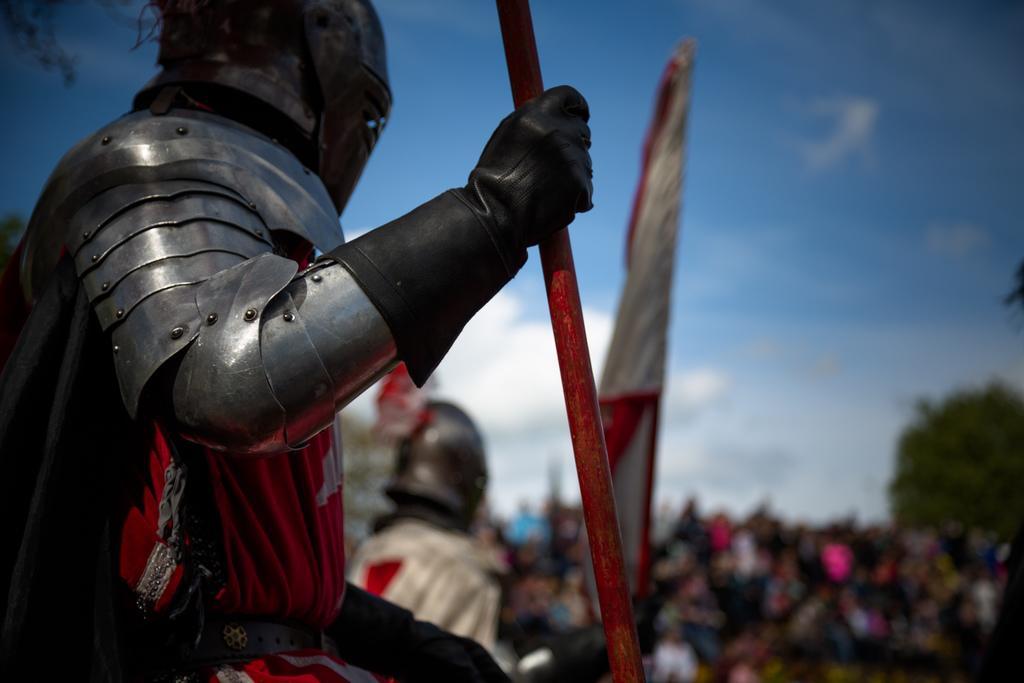Describe this image in one or two sentences. In this image we can see few people, a person is holding a rod and a person is holding a flag, there is a tree and sky in the background. 